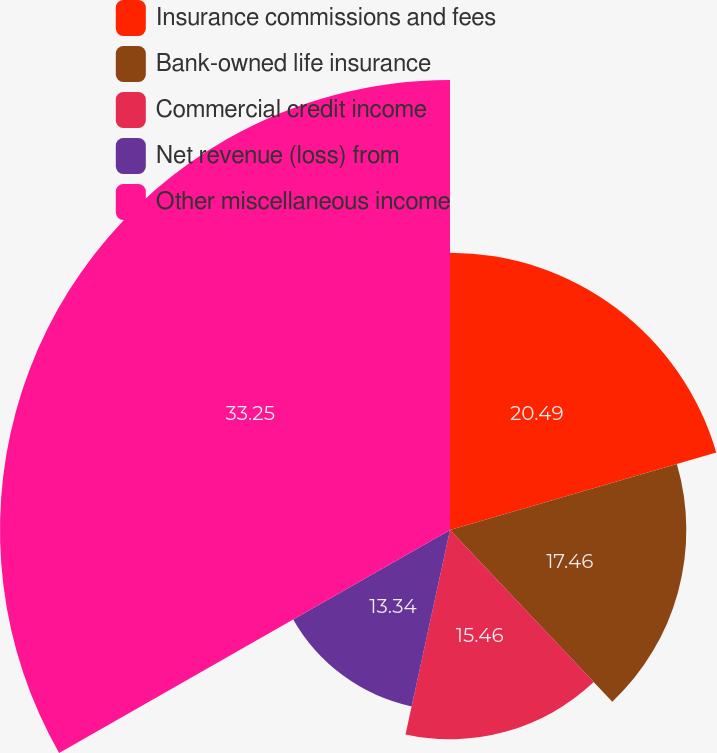Convert chart to OTSL. <chart><loc_0><loc_0><loc_500><loc_500><pie_chart><fcel>Insurance commissions and fees<fcel>Bank-owned life insurance<fcel>Commercial credit income<fcel>Net revenue (loss) from<fcel>Other miscellaneous income<nl><fcel>20.49%<fcel>17.46%<fcel>15.46%<fcel>13.34%<fcel>33.25%<nl></chart> 